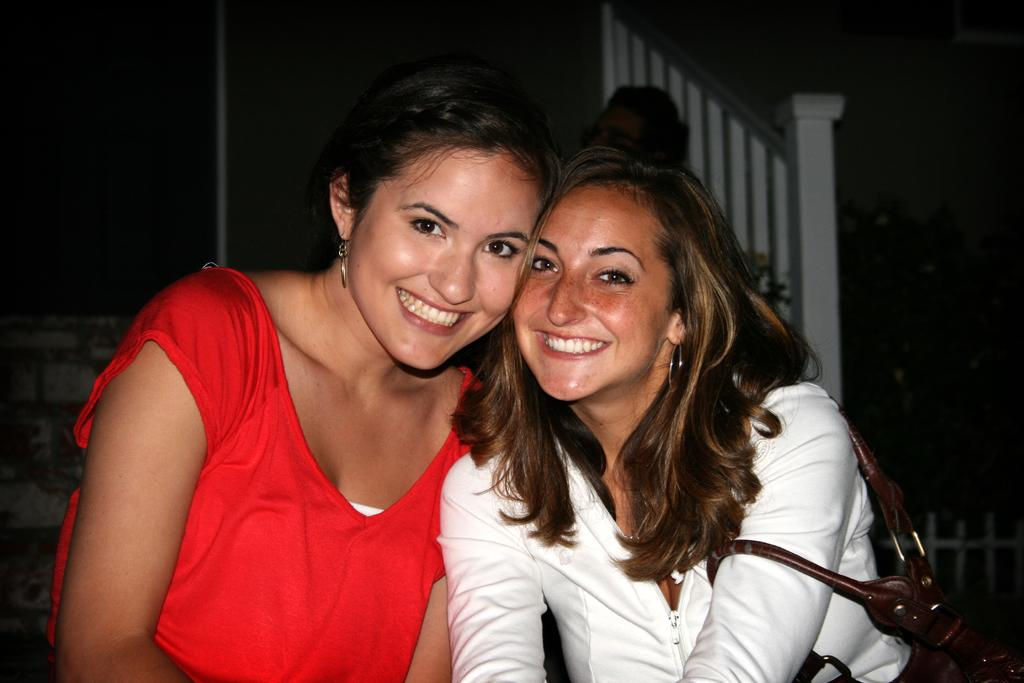How many women are in the image? There are two women in the image. What are the women doing in the image? The women are smiling in the front of the image. What is one of the women holding? One of the women is carrying a bag. Can you describe the background of the image? The background of the image is dark. What type of bottle is being used for business purposes in the image? There is no bottle present in the image, and no business-related activities are depicted. 